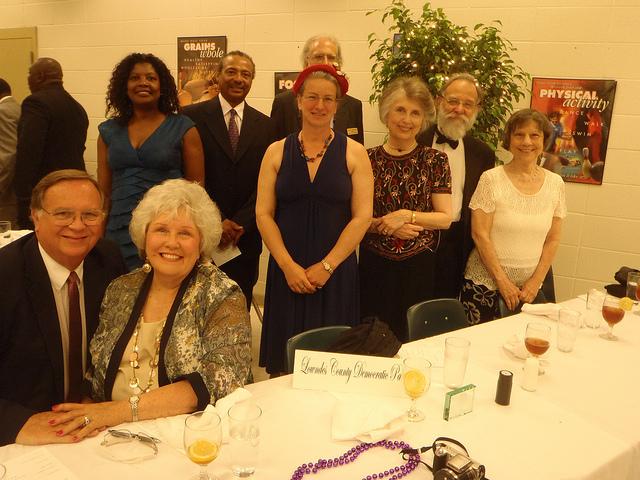Who has a full gray beard?
Give a very brief answer. Man. Are these people eating?
Write a very short answer. No. What holiday is represented by this picture?
Short answer required. Mardi gras. Is this a formal dinner?
Short answer required. Yes. Where are the men and women in the photo?
Give a very brief answer. Party. Are the people related?
Quick response, please. Yes. How many people are raising hands?
Quick response, please. 0. What kind of dress is she wearing?
Short answer required. Formal. Are the people looking at the camera adults?
Answer briefly. Yes. Are these people sad?
Short answer required. No. 